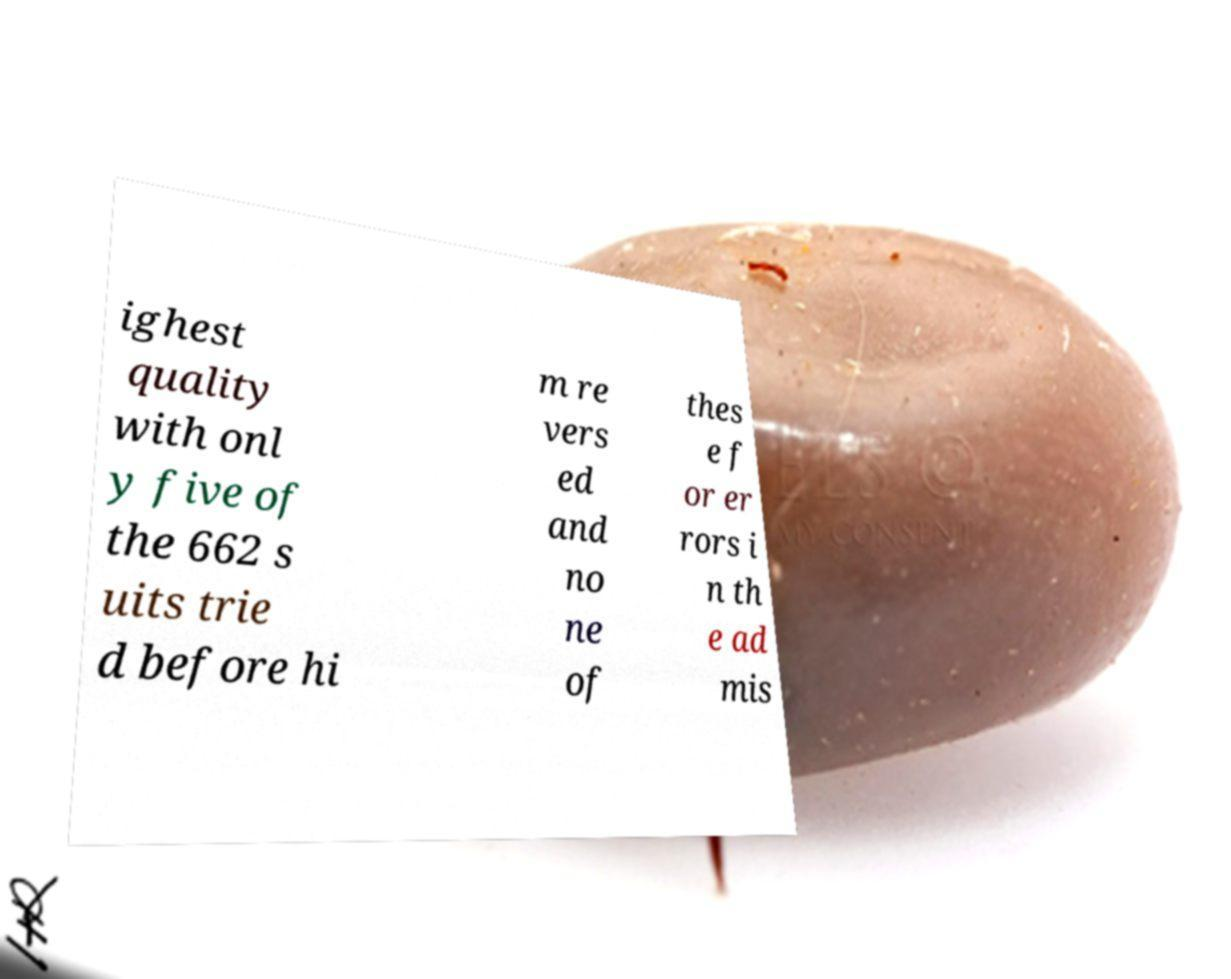Can you read and provide the text displayed in the image?This photo seems to have some interesting text. Can you extract and type it out for me? ighest quality with onl y five of the 662 s uits trie d before hi m re vers ed and no ne of thes e f or er rors i n th e ad mis 